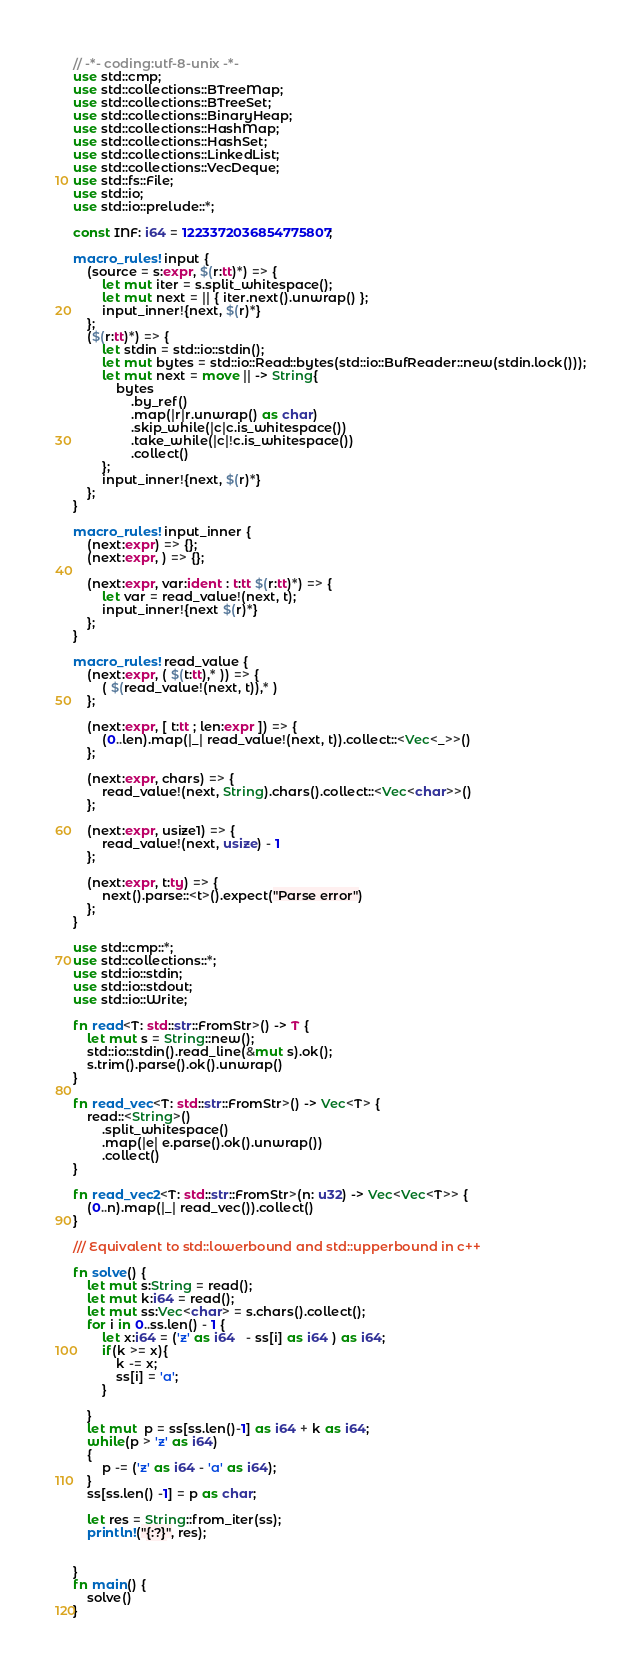<code> <loc_0><loc_0><loc_500><loc_500><_Rust_>// -*- coding:utf-8-unix -*-
use std::cmp;
use std::collections::BTreeMap;
use std::collections::BTreeSet;
use std::collections::BinaryHeap;
use std::collections::HashMap;
use std::collections::HashSet;
use std::collections::LinkedList;
use std::collections::VecDeque;
use std::fs::File;
use std::io;
use std::io::prelude::*;

const INF: i64 = 1223372036854775807;

macro_rules! input {
    (source = s:expr, $(r:tt)*) => {
        let mut iter = s.split_whitespace();
        let mut next = || { iter.next().unwrap() };
        input_inner!{next, $(r)*}
    };
    ($(r:tt)*) => {
        let stdin = std::io::stdin();
        let mut bytes = std::io::Read::bytes(std::io::BufReader::new(stdin.lock()));
        let mut next = move || -> String{
            bytes
                .by_ref()
                .map(|r|r.unwrap() as char)
                .skip_while(|c|c.is_whitespace())
                .take_while(|c|!c.is_whitespace())
                .collect()
        };
        input_inner!{next, $(r)*}
    };
}

macro_rules! input_inner {
    (next:expr) => {};
    (next:expr, ) => {};

    (next:expr, var:ident : t:tt $(r:tt)*) => {
        let var = read_value!(next, t);
        input_inner!{next $(r)*}
    };
}

macro_rules! read_value {
    (next:expr, ( $(t:tt),* )) => {
        ( $(read_value!(next, t)),* )
    };

    (next:expr, [ t:tt ; len:expr ]) => {
        (0..len).map(|_| read_value!(next, t)).collect::<Vec<_>>()
    };

    (next:expr, chars) => {
        read_value!(next, String).chars().collect::<Vec<char>>()
    };

    (next:expr, usize1) => {
        read_value!(next, usize) - 1
    };

    (next:expr, t:ty) => {
        next().parse::<t>().expect("Parse error")
    };
}

use std::cmp::*;
use std::collections::*;
use std::io::stdin;
use std::io::stdout;
use std::io::Write;

fn read<T: std::str::FromStr>() -> T {
    let mut s = String::new();
    std::io::stdin().read_line(&mut s).ok();
    s.trim().parse().ok().unwrap()
}

fn read_vec<T: std::str::FromStr>() -> Vec<T> {
    read::<String>()
        .split_whitespace()
        .map(|e| e.parse().ok().unwrap())
        .collect()
}

fn read_vec2<T: std::str::FromStr>(n: u32) -> Vec<Vec<T>> {
    (0..n).map(|_| read_vec()).collect()
}

/// Equivalent to std::lowerbound and std::upperbound in c++

fn solve() {
    let mut s:String = read();
    let mut k:i64 = read();
    let mut ss:Vec<char> = s.chars().collect();
    for i in 0..ss.len() - 1 {
        let x:i64 = ('z' as i64   - ss[i] as i64 ) as i64;
        if(k >= x){
            k -= x;
            ss[i] = 'a';
        }

    }
    let mut  p = ss[ss.len()-1] as i64 + k as i64;
    while(p > 'z' as i64)
    {
        p -= ('z' as i64 - 'a' as i64);
    }
    ss[ss.len() -1] = p as char;

    let res = String::from_iter(ss);
    println!("{:?}", res);

    
}
fn main() {
    solve()
}
</code> 